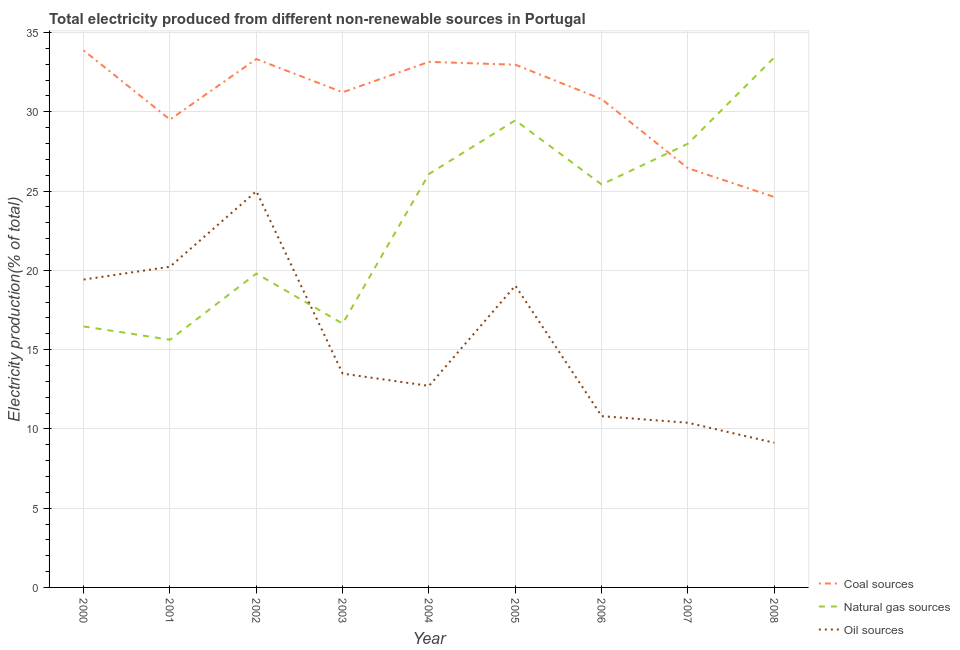Is the number of lines equal to the number of legend labels?
Offer a very short reply. Yes. What is the percentage of electricity produced by natural gas in 2004?
Your answer should be compact. 26.08. Across all years, what is the maximum percentage of electricity produced by coal?
Provide a short and direct response. 33.87. Across all years, what is the minimum percentage of electricity produced by natural gas?
Offer a very short reply. 15.62. What is the total percentage of electricity produced by coal in the graph?
Offer a very short reply. 275.88. What is the difference between the percentage of electricity produced by coal in 2000 and that in 2001?
Provide a short and direct response. 4.36. What is the difference between the percentage of electricity produced by oil sources in 2005 and the percentage of electricity produced by coal in 2001?
Your answer should be compact. -10.47. What is the average percentage of electricity produced by oil sources per year?
Your answer should be compact. 15.57. In the year 2008, what is the difference between the percentage of electricity produced by coal and percentage of electricity produced by oil sources?
Provide a succinct answer. 15.5. In how many years, is the percentage of electricity produced by oil sources greater than 27 %?
Keep it short and to the point. 0. What is the ratio of the percentage of electricity produced by natural gas in 2002 to that in 2003?
Offer a terse response. 1.19. Is the percentage of electricity produced by coal in 2002 less than that in 2006?
Offer a terse response. No. What is the difference between the highest and the second highest percentage of electricity produced by natural gas?
Give a very brief answer. 3.97. What is the difference between the highest and the lowest percentage of electricity produced by oil sources?
Give a very brief answer. 15.87. Is it the case that in every year, the sum of the percentage of electricity produced by coal and percentage of electricity produced by natural gas is greater than the percentage of electricity produced by oil sources?
Keep it short and to the point. Yes. Does the percentage of electricity produced by natural gas monotonically increase over the years?
Offer a terse response. No. Is the percentage of electricity produced by natural gas strictly greater than the percentage of electricity produced by coal over the years?
Your answer should be compact. No. Is the percentage of electricity produced by coal strictly less than the percentage of electricity produced by natural gas over the years?
Give a very brief answer. No. Does the graph contain any zero values?
Ensure brevity in your answer.  No. Does the graph contain grids?
Provide a short and direct response. Yes. Where does the legend appear in the graph?
Your response must be concise. Bottom right. How are the legend labels stacked?
Offer a terse response. Vertical. What is the title of the graph?
Give a very brief answer. Total electricity produced from different non-renewable sources in Portugal. What is the label or title of the Y-axis?
Ensure brevity in your answer.  Electricity production(% of total). What is the Electricity production(% of total) of Coal sources in 2000?
Provide a succinct answer. 33.87. What is the Electricity production(% of total) of Natural gas sources in 2000?
Your response must be concise. 16.46. What is the Electricity production(% of total) in Oil sources in 2000?
Your answer should be compact. 19.42. What is the Electricity production(% of total) of Coal sources in 2001?
Provide a succinct answer. 29.51. What is the Electricity production(% of total) of Natural gas sources in 2001?
Give a very brief answer. 15.62. What is the Electricity production(% of total) in Oil sources in 2001?
Give a very brief answer. 20.23. What is the Electricity production(% of total) of Coal sources in 2002?
Offer a very short reply. 33.32. What is the Electricity production(% of total) in Natural gas sources in 2002?
Make the answer very short. 19.8. What is the Electricity production(% of total) in Oil sources in 2002?
Offer a terse response. 24.99. What is the Electricity production(% of total) in Coal sources in 2003?
Ensure brevity in your answer.  31.23. What is the Electricity production(% of total) in Natural gas sources in 2003?
Provide a short and direct response. 16.64. What is the Electricity production(% of total) in Oil sources in 2003?
Ensure brevity in your answer.  13.48. What is the Electricity production(% of total) of Coal sources in 2004?
Your answer should be compact. 33.15. What is the Electricity production(% of total) of Natural gas sources in 2004?
Make the answer very short. 26.08. What is the Electricity production(% of total) of Oil sources in 2004?
Ensure brevity in your answer.  12.71. What is the Electricity production(% of total) in Coal sources in 2005?
Keep it short and to the point. 32.97. What is the Electricity production(% of total) of Natural gas sources in 2005?
Ensure brevity in your answer.  29.46. What is the Electricity production(% of total) of Oil sources in 2005?
Provide a succinct answer. 19.03. What is the Electricity production(% of total) in Coal sources in 2006?
Keep it short and to the point. 30.79. What is the Electricity production(% of total) of Natural gas sources in 2006?
Your answer should be very brief. 25.41. What is the Electricity production(% of total) in Oil sources in 2006?
Provide a succinct answer. 10.8. What is the Electricity production(% of total) in Coal sources in 2007?
Offer a very short reply. 26.44. What is the Electricity production(% of total) in Natural gas sources in 2007?
Give a very brief answer. 27.99. What is the Electricity production(% of total) of Oil sources in 2007?
Ensure brevity in your answer.  10.38. What is the Electricity production(% of total) in Coal sources in 2008?
Ensure brevity in your answer.  24.62. What is the Electricity production(% of total) in Natural gas sources in 2008?
Provide a short and direct response. 33.43. What is the Electricity production(% of total) of Oil sources in 2008?
Provide a succinct answer. 9.12. Across all years, what is the maximum Electricity production(% of total) in Coal sources?
Provide a short and direct response. 33.87. Across all years, what is the maximum Electricity production(% of total) in Natural gas sources?
Your answer should be compact. 33.43. Across all years, what is the maximum Electricity production(% of total) in Oil sources?
Provide a succinct answer. 24.99. Across all years, what is the minimum Electricity production(% of total) of Coal sources?
Provide a short and direct response. 24.62. Across all years, what is the minimum Electricity production(% of total) in Natural gas sources?
Offer a terse response. 15.62. Across all years, what is the minimum Electricity production(% of total) in Oil sources?
Offer a very short reply. 9.12. What is the total Electricity production(% of total) in Coal sources in the graph?
Ensure brevity in your answer.  275.88. What is the total Electricity production(% of total) of Natural gas sources in the graph?
Your answer should be very brief. 210.87. What is the total Electricity production(% of total) of Oil sources in the graph?
Provide a succinct answer. 140.17. What is the difference between the Electricity production(% of total) of Coal sources in 2000 and that in 2001?
Provide a succinct answer. 4.36. What is the difference between the Electricity production(% of total) in Natural gas sources in 2000 and that in 2001?
Make the answer very short. 0.84. What is the difference between the Electricity production(% of total) in Oil sources in 2000 and that in 2001?
Offer a very short reply. -0.81. What is the difference between the Electricity production(% of total) of Coal sources in 2000 and that in 2002?
Offer a very short reply. 0.54. What is the difference between the Electricity production(% of total) of Natural gas sources in 2000 and that in 2002?
Provide a short and direct response. -3.34. What is the difference between the Electricity production(% of total) in Oil sources in 2000 and that in 2002?
Your answer should be very brief. -5.57. What is the difference between the Electricity production(% of total) of Coal sources in 2000 and that in 2003?
Keep it short and to the point. 2.64. What is the difference between the Electricity production(% of total) in Natural gas sources in 2000 and that in 2003?
Your answer should be compact. -0.18. What is the difference between the Electricity production(% of total) of Oil sources in 2000 and that in 2003?
Provide a short and direct response. 5.93. What is the difference between the Electricity production(% of total) in Coal sources in 2000 and that in 2004?
Your answer should be very brief. 0.72. What is the difference between the Electricity production(% of total) of Natural gas sources in 2000 and that in 2004?
Give a very brief answer. -9.62. What is the difference between the Electricity production(% of total) in Oil sources in 2000 and that in 2004?
Offer a terse response. 6.7. What is the difference between the Electricity production(% of total) of Coal sources in 2000 and that in 2005?
Offer a terse response. 0.9. What is the difference between the Electricity production(% of total) of Natural gas sources in 2000 and that in 2005?
Ensure brevity in your answer.  -13. What is the difference between the Electricity production(% of total) of Oil sources in 2000 and that in 2005?
Offer a very short reply. 0.38. What is the difference between the Electricity production(% of total) of Coal sources in 2000 and that in 2006?
Keep it short and to the point. 3.07. What is the difference between the Electricity production(% of total) in Natural gas sources in 2000 and that in 2006?
Provide a short and direct response. -8.95. What is the difference between the Electricity production(% of total) of Oil sources in 2000 and that in 2006?
Make the answer very short. 8.61. What is the difference between the Electricity production(% of total) in Coal sources in 2000 and that in 2007?
Your answer should be compact. 7.43. What is the difference between the Electricity production(% of total) of Natural gas sources in 2000 and that in 2007?
Offer a terse response. -11.53. What is the difference between the Electricity production(% of total) of Oil sources in 2000 and that in 2007?
Offer a very short reply. 9.03. What is the difference between the Electricity production(% of total) in Coal sources in 2000 and that in 2008?
Your answer should be very brief. 9.24. What is the difference between the Electricity production(% of total) of Natural gas sources in 2000 and that in 2008?
Make the answer very short. -16.97. What is the difference between the Electricity production(% of total) in Oil sources in 2000 and that in 2008?
Provide a short and direct response. 10.29. What is the difference between the Electricity production(% of total) in Coal sources in 2001 and that in 2002?
Make the answer very short. -3.82. What is the difference between the Electricity production(% of total) in Natural gas sources in 2001 and that in 2002?
Make the answer very short. -4.18. What is the difference between the Electricity production(% of total) in Oil sources in 2001 and that in 2002?
Ensure brevity in your answer.  -4.76. What is the difference between the Electricity production(% of total) of Coal sources in 2001 and that in 2003?
Keep it short and to the point. -1.72. What is the difference between the Electricity production(% of total) of Natural gas sources in 2001 and that in 2003?
Your answer should be very brief. -1.02. What is the difference between the Electricity production(% of total) in Oil sources in 2001 and that in 2003?
Give a very brief answer. 6.74. What is the difference between the Electricity production(% of total) of Coal sources in 2001 and that in 2004?
Your answer should be very brief. -3.64. What is the difference between the Electricity production(% of total) of Natural gas sources in 2001 and that in 2004?
Provide a short and direct response. -10.45. What is the difference between the Electricity production(% of total) of Oil sources in 2001 and that in 2004?
Offer a very short reply. 7.51. What is the difference between the Electricity production(% of total) in Coal sources in 2001 and that in 2005?
Ensure brevity in your answer.  -3.46. What is the difference between the Electricity production(% of total) in Natural gas sources in 2001 and that in 2005?
Offer a terse response. -13.84. What is the difference between the Electricity production(% of total) in Oil sources in 2001 and that in 2005?
Make the answer very short. 1.19. What is the difference between the Electricity production(% of total) in Coal sources in 2001 and that in 2006?
Your answer should be very brief. -1.29. What is the difference between the Electricity production(% of total) of Natural gas sources in 2001 and that in 2006?
Provide a succinct answer. -9.79. What is the difference between the Electricity production(% of total) in Oil sources in 2001 and that in 2006?
Ensure brevity in your answer.  9.42. What is the difference between the Electricity production(% of total) of Coal sources in 2001 and that in 2007?
Provide a succinct answer. 3.07. What is the difference between the Electricity production(% of total) of Natural gas sources in 2001 and that in 2007?
Your response must be concise. -12.36. What is the difference between the Electricity production(% of total) in Oil sources in 2001 and that in 2007?
Make the answer very short. 9.84. What is the difference between the Electricity production(% of total) in Coal sources in 2001 and that in 2008?
Offer a terse response. 4.88. What is the difference between the Electricity production(% of total) of Natural gas sources in 2001 and that in 2008?
Provide a succinct answer. -17.8. What is the difference between the Electricity production(% of total) in Oil sources in 2001 and that in 2008?
Provide a short and direct response. 11.1. What is the difference between the Electricity production(% of total) of Coal sources in 2002 and that in 2003?
Give a very brief answer. 2.1. What is the difference between the Electricity production(% of total) in Natural gas sources in 2002 and that in 2003?
Give a very brief answer. 3.16. What is the difference between the Electricity production(% of total) in Oil sources in 2002 and that in 2003?
Provide a succinct answer. 11.5. What is the difference between the Electricity production(% of total) of Coal sources in 2002 and that in 2004?
Offer a very short reply. 0.18. What is the difference between the Electricity production(% of total) of Natural gas sources in 2002 and that in 2004?
Keep it short and to the point. -6.28. What is the difference between the Electricity production(% of total) in Oil sources in 2002 and that in 2004?
Your response must be concise. 12.28. What is the difference between the Electricity production(% of total) in Coal sources in 2002 and that in 2005?
Offer a terse response. 0.36. What is the difference between the Electricity production(% of total) of Natural gas sources in 2002 and that in 2005?
Give a very brief answer. -9.66. What is the difference between the Electricity production(% of total) of Oil sources in 2002 and that in 2005?
Your answer should be compact. 5.95. What is the difference between the Electricity production(% of total) of Coal sources in 2002 and that in 2006?
Your response must be concise. 2.53. What is the difference between the Electricity production(% of total) in Natural gas sources in 2002 and that in 2006?
Your response must be concise. -5.61. What is the difference between the Electricity production(% of total) of Oil sources in 2002 and that in 2006?
Your response must be concise. 14.19. What is the difference between the Electricity production(% of total) in Coal sources in 2002 and that in 2007?
Your answer should be very brief. 6.89. What is the difference between the Electricity production(% of total) in Natural gas sources in 2002 and that in 2007?
Your answer should be compact. -8.19. What is the difference between the Electricity production(% of total) in Oil sources in 2002 and that in 2007?
Provide a succinct answer. 14.6. What is the difference between the Electricity production(% of total) of Coal sources in 2002 and that in 2008?
Your answer should be very brief. 8.7. What is the difference between the Electricity production(% of total) of Natural gas sources in 2002 and that in 2008?
Your response must be concise. -13.63. What is the difference between the Electricity production(% of total) of Oil sources in 2002 and that in 2008?
Your answer should be compact. 15.87. What is the difference between the Electricity production(% of total) of Coal sources in 2003 and that in 2004?
Provide a succinct answer. -1.92. What is the difference between the Electricity production(% of total) of Natural gas sources in 2003 and that in 2004?
Your response must be concise. -9.44. What is the difference between the Electricity production(% of total) in Oil sources in 2003 and that in 2004?
Keep it short and to the point. 0.77. What is the difference between the Electricity production(% of total) in Coal sources in 2003 and that in 2005?
Your answer should be compact. -1.74. What is the difference between the Electricity production(% of total) in Natural gas sources in 2003 and that in 2005?
Your answer should be compact. -12.82. What is the difference between the Electricity production(% of total) of Oil sources in 2003 and that in 2005?
Keep it short and to the point. -5.55. What is the difference between the Electricity production(% of total) of Coal sources in 2003 and that in 2006?
Offer a very short reply. 0.43. What is the difference between the Electricity production(% of total) of Natural gas sources in 2003 and that in 2006?
Offer a very short reply. -8.77. What is the difference between the Electricity production(% of total) of Oil sources in 2003 and that in 2006?
Your answer should be compact. 2.68. What is the difference between the Electricity production(% of total) of Coal sources in 2003 and that in 2007?
Your response must be concise. 4.79. What is the difference between the Electricity production(% of total) in Natural gas sources in 2003 and that in 2007?
Offer a terse response. -11.35. What is the difference between the Electricity production(% of total) in Oil sources in 2003 and that in 2007?
Your answer should be compact. 3.1. What is the difference between the Electricity production(% of total) of Coal sources in 2003 and that in 2008?
Make the answer very short. 6.6. What is the difference between the Electricity production(% of total) of Natural gas sources in 2003 and that in 2008?
Keep it short and to the point. -16.79. What is the difference between the Electricity production(% of total) in Oil sources in 2003 and that in 2008?
Your answer should be compact. 4.36. What is the difference between the Electricity production(% of total) of Coal sources in 2004 and that in 2005?
Offer a very short reply. 0.18. What is the difference between the Electricity production(% of total) in Natural gas sources in 2004 and that in 2005?
Offer a terse response. -3.38. What is the difference between the Electricity production(% of total) of Oil sources in 2004 and that in 2005?
Provide a short and direct response. -6.32. What is the difference between the Electricity production(% of total) of Coal sources in 2004 and that in 2006?
Make the answer very short. 2.35. What is the difference between the Electricity production(% of total) in Natural gas sources in 2004 and that in 2006?
Ensure brevity in your answer.  0.67. What is the difference between the Electricity production(% of total) in Oil sources in 2004 and that in 2006?
Give a very brief answer. 1.91. What is the difference between the Electricity production(% of total) in Coal sources in 2004 and that in 2007?
Offer a terse response. 6.71. What is the difference between the Electricity production(% of total) in Natural gas sources in 2004 and that in 2007?
Your response must be concise. -1.91. What is the difference between the Electricity production(% of total) of Oil sources in 2004 and that in 2007?
Give a very brief answer. 2.33. What is the difference between the Electricity production(% of total) of Coal sources in 2004 and that in 2008?
Give a very brief answer. 8.52. What is the difference between the Electricity production(% of total) in Natural gas sources in 2004 and that in 2008?
Provide a short and direct response. -7.35. What is the difference between the Electricity production(% of total) in Oil sources in 2004 and that in 2008?
Provide a succinct answer. 3.59. What is the difference between the Electricity production(% of total) in Coal sources in 2005 and that in 2006?
Ensure brevity in your answer.  2.17. What is the difference between the Electricity production(% of total) in Natural gas sources in 2005 and that in 2006?
Provide a short and direct response. 4.05. What is the difference between the Electricity production(% of total) in Oil sources in 2005 and that in 2006?
Your answer should be compact. 8.23. What is the difference between the Electricity production(% of total) in Coal sources in 2005 and that in 2007?
Give a very brief answer. 6.53. What is the difference between the Electricity production(% of total) in Natural gas sources in 2005 and that in 2007?
Your answer should be compact. 1.47. What is the difference between the Electricity production(% of total) of Oil sources in 2005 and that in 2007?
Provide a succinct answer. 8.65. What is the difference between the Electricity production(% of total) of Coal sources in 2005 and that in 2008?
Keep it short and to the point. 8.34. What is the difference between the Electricity production(% of total) in Natural gas sources in 2005 and that in 2008?
Offer a very short reply. -3.97. What is the difference between the Electricity production(% of total) in Oil sources in 2005 and that in 2008?
Provide a short and direct response. 9.91. What is the difference between the Electricity production(% of total) in Coal sources in 2006 and that in 2007?
Your response must be concise. 4.36. What is the difference between the Electricity production(% of total) of Natural gas sources in 2006 and that in 2007?
Offer a very short reply. -2.58. What is the difference between the Electricity production(% of total) in Oil sources in 2006 and that in 2007?
Offer a terse response. 0.42. What is the difference between the Electricity production(% of total) of Coal sources in 2006 and that in 2008?
Provide a succinct answer. 6.17. What is the difference between the Electricity production(% of total) of Natural gas sources in 2006 and that in 2008?
Ensure brevity in your answer.  -8.02. What is the difference between the Electricity production(% of total) of Oil sources in 2006 and that in 2008?
Ensure brevity in your answer.  1.68. What is the difference between the Electricity production(% of total) in Coal sources in 2007 and that in 2008?
Your answer should be compact. 1.81. What is the difference between the Electricity production(% of total) in Natural gas sources in 2007 and that in 2008?
Ensure brevity in your answer.  -5.44. What is the difference between the Electricity production(% of total) of Oil sources in 2007 and that in 2008?
Your response must be concise. 1.26. What is the difference between the Electricity production(% of total) in Coal sources in 2000 and the Electricity production(% of total) in Natural gas sources in 2001?
Give a very brief answer. 18.24. What is the difference between the Electricity production(% of total) in Coal sources in 2000 and the Electricity production(% of total) in Oil sources in 2001?
Ensure brevity in your answer.  13.64. What is the difference between the Electricity production(% of total) in Natural gas sources in 2000 and the Electricity production(% of total) in Oil sources in 2001?
Offer a terse response. -3.77. What is the difference between the Electricity production(% of total) of Coal sources in 2000 and the Electricity production(% of total) of Natural gas sources in 2002?
Provide a succinct answer. 14.07. What is the difference between the Electricity production(% of total) in Coal sources in 2000 and the Electricity production(% of total) in Oil sources in 2002?
Provide a succinct answer. 8.88. What is the difference between the Electricity production(% of total) of Natural gas sources in 2000 and the Electricity production(% of total) of Oil sources in 2002?
Your answer should be very brief. -8.53. What is the difference between the Electricity production(% of total) in Coal sources in 2000 and the Electricity production(% of total) in Natural gas sources in 2003?
Keep it short and to the point. 17.23. What is the difference between the Electricity production(% of total) of Coal sources in 2000 and the Electricity production(% of total) of Oil sources in 2003?
Your answer should be very brief. 20.38. What is the difference between the Electricity production(% of total) in Natural gas sources in 2000 and the Electricity production(% of total) in Oil sources in 2003?
Make the answer very short. 2.97. What is the difference between the Electricity production(% of total) in Coal sources in 2000 and the Electricity production(% of total) in Natural gas sources in 2004?
Make the answer very short. 7.79. What is the difference between the Electricity production(% of total) in Coal sources in 2000 and the Electricity production(% of total) in Oil sources in 2004?
Ensure brevity in your answer.  21.15. What is the difference between the Electricity production(% of total) in Natural gas sources in 2000 and the Electricity production(% of total) in Oil sources in 2004?
Make the answer very short. 3.75. What is the difference between the Electricity production(% of total) of Coal sources in 2000 and the Electricity production(% of total) of Natural gas sources in 2005?
Your answer should be very brief. 4.41. What is the difference between the Electricity production(% of total) in Coal sources in 2000 and the Electricity production(% of total) in Oil sources in 2005?
Make the answer very short. 14.83. What is the difference between the Electricity production(% of total) of Natural gas sources in 2000 and the Electricity production(% of total) of Oil sources in 2005?
Offer a very short reply. -2.58. What is the difference between the Electricity production(% of total) of Coal sources in 2000 and the Electricity production(% of total) of Natural gas sources in 2006?
Provide a succinct answer. 8.46. What is the difference between the Electricity production(% of total) of Coal sources in 2000 and the Electricity production(% of total) of Oil sources in 2006?
Ensure brevity in your answer.  23.06. What is the difference between the Electricity production(% of total) of Natural gas sources in 2000 and the Electricity production(% of total) of Oil sources in 2006?
Offer a very short reply. 5.66. What is the difference between the Electricity production(% of total) of Coal sources in 2000 and the Electricity production(% of total) of Natural gas sources in 2007?
Give a very brief answer. 5.88. What is the difference between the Electricity production(% of total) in Coal sources in 2000 and the Electricity production(% of total) in Oil sources in 2007?
Make the answer very short. 23.48. What is the difference between the Electricity production(% of total) in Natural gas sources in 2000 and the Electricity production(% of total) in Oil sources in 2007?
Offer a very short reply. 6.07. What is the difference between the Electricity production(% of total) of Coal sources in 2000 and the Electricity production(% of total) of Natural gas sources in 2008?
Ensure brevity in your answer.  0.44. What is the difference between the Electricity production(% of total) in Coal sources in 2000 and the Electricity production(% of total) in Oil sources in 2008?
Make the answer very short. 24.74. What is the difference between the Electricity production(% of total) of Natural gas sources in 2000 and the Electricity production(% of total) of Oil sources in 2008?
Your answer should be compact. 7.34. What is the difference between the Electricity production(% of total) in Coal sources in 2001 and the Electricity production(% of total) in Natural gas sources in 2002?
Offer a terse response. 9.71. What is the difference between the Electricity production(% of total) of Coal sources in 2001 and the Electricity production(% of total) of Oil sources in 2002?
Ensure brevity in your answer.  4.52. What is the difference between the Electricity production(% of total) of Natural gas sources in 2001 and the Electricity production(% of total) of Oil sources in 2002?
Make the answer very short. -9.37. What is the difference between the Electricity production(% of total) in Coal sources in 2001 and the Electricity production(% of total) in Natural gas sources in 2003?
Offer a very short reply. 12.87. What is the difference between the Electricity production(% of total) in Coal sources in 2001 and the Electricity production(% of total) in Oil sources in 2003?
Offer a very short reply. 16.02. What is the difference between the Electricity production(% of total) in Natural gas sources in 2001 and the Electricity production(% of total) in Oil sources in 2003?
Keep it short and to the point. 2.14. What is the difference between the Electricity production(% of total) of Coal sources in 2001 and the Electricity production(% of total) of Natural gas sources in 2004?
Give a very brief answer. 3.43. What is the difference between the Electricity production(% of total) of Coal sources in 2001 and the Electricity production(% of total) of Oil sources in 2004?
Offer a very short reply. 16.79. What is the difference between the Electricity production(% of total) in Natural gas sources in 2001 and the Electricity production(% of total) in Oil sources in 2004?
Give a very brief answer. 2.91. What is the difference between the Electricity production(% of total) of Coal sources in 2001 and the Electricity production(% of total) of Natural gas sources in 2005?
Your answer should be compact. 0.05. What is the difference between the Electricity production(% of total) in Coal sources in 2001 and the Electricity production(% of total) in Oil sources in 2005?
Offer a very short reply. 10.47. What is the difference between the Electricity production(% of total) of Natural gas sources in 2001 and the Electricity production(% of total) of Oil sources in 2005?
Give a very brief answer. -3.41. What is the difference between the Electricity production(% of total) in Coal sources in 2001 and the Electricity production(% of total) in Natural gas sources in 2006?
Provide a short and direct response. 4.1. What is the difference between the Electricity production(% of total) in Coal sources in 2001 and the Electricity production(% of total) in Oil sources in 2006?
Make the answer very short. 18.7. What is the difference between the Electricity production(% of total) of Natural gas sources in 2001 and the Electricity production(% of total) of Oil sources in 2006?
Your answer should be very brief. 4.82. What is the difference between the Electricity production(% of total) in Coal sources in 2001 and the Electricity production(% of total) in Natural gas sources in 2007?
Your answer should be very brief. 1.52. What is the difference between the Electricity production(% of total) of Coal sources in 2001 and the Electricity production(% of total) of Oil sources in 2007?
Your answer should be very brief. 19.12. What is the difference between the Electricity production(% of total) of Natural gas sources in 2001 and the Electricity production(% of total) of Oil sources in 2007?
Your answer should be very brief. 5.24. What is the difference between the Electricity production(% of total) in Coal sources in 2001 and the Electricity production(% of total) in Natural gas sources in 2008?
Make the answer very short. -3.92. What is the difference between the Electricity production(% of total) in Coal sources in 2001 and the Electricity production(% of total) in Oil sources in 2008?
Provide a succinct answer. 20.38. What is the difference between the Electricity production(% of total) in Natural gas sources in 2001 and the Electricity production(% of total) in Oil sources in 2008?
Your answer should be very brief. 6.5. What is the difference between the Electricity production(% of total) of Coal sources in 2002 and the Electricity production(% of total) of Natural gas sources in 2003?
Your answer should be very brief. 16.69. What is the difference between the Electricity production(% of total) of Coal sources in 2002 and the Electricity production(% of total) of Oil sources in 2003?
Make the answer very short. 19.84. What is the difference between the Electricity production(% of total) in Natural gas sources in 2002 and the Electricity production(% of total) in Oil sources in 2003?
Your response must be concise. 6.31. What is the difference between the Electricity production(% of total) of Coal sources in 2002 and the Electricity production(% of total) of Natural gas sources in 2004?
Provide a short and direct response. 7.25. What is the difference between the Electricity production(% of total) of Coal sources in 2002 and the Electricity production(% of total) of Oil sources in 2004?
Give a very brief answer. 20.61. What is the difference between the Electricity production(% of total) in Natural gas sources in 2002 and the Electricity production(% of total) in Oil sources in 2004?
Provide a short and direct response. 7.09. What is the difference between the Electricity production(% of total) of Coal sources in 2002 and the Electricity production(% of total) of Natural gas sources in 2005?
Give a very brief answer. 3.87. What is the difference between the Electricity production(% of total) in Coal sources in 2002 and the Electricity production(% of total) in Oil sources in 2005?
Give a very brief answer. 14.29. What is the difference between the Electricity production(% of total) in Natural gas sources in 2002 and the Electricity production(% of total) in Oil sources in 2005?
Your response must be concise. 0.76. What is the difference between the Electricity production(% of total) of Coal sources in 2002 and the Electricity production(% of total) of Natural gas sources in 2006?
Give a very brief answer. 7.91. What is the difference between the Electricity production(% of total) in Coal sources in 2002 and the Electricity production(% of total) in Oil sources in 2006?
Your response must be concise. 22.52. What is the difference between the Electricity production(% of total) in Natural gas sources in 2002 and the Electricity production(% of total) in Oil sources in 2006?
Provide a succinct answer. 8.99. What is the difference between the Electricity production(% of total) of Coal sources in 2002 and the Electricity production(% of total) of Natural gas sources in 2007?
Give a very brief answer. 5.34. What is the difference between the Electricity production(% of total) of Coal sources in 2002 and the Electricity production(% of total) of Oil sources in 2007?
Offer a very short reply. 22.94. What is the difference between the Electricity production(% of total) in Natural gas sources in 2002 and the Electricity production(% of total) in Oil sources in 2007?
Offer a very short reply. 9.41. What is the difference between the Electricity production(% of total) in Coal sources in 2002 and the Electricity production(% of total) in Natural gas sources in 2008?
Keep it short and to the point. -0.1. What is the difference between the Electricity production(% of total) of Coal sources in 2002 and the Electricity production(% of total) of Oil sources in 2008?
Give a very brief answer. 24.2. What is the difference between the Electricity production(% of total) of Natural gas sources in 2002 and the Electricity production(% of total) of Oil sources in 2008?
Keep it short and to the point. 10.67. What is the difference between the Electricity production(% of total) of Coal sources in 2003 and the Electricity production(% of total) of Natural gas sources in 2004?
Your answer should be very brief. 5.15. What is the difference between the Electricity production(% of total) of Coal sources in 2003 and the Electricity production(% of total) of Oil sources in 2004?
Keep it short and to the point. 18.52. What is the difference between the Electricity production(% of total) of Natural gas sources in 2003 and the Electricity production(% of total) of Oil sources in 2004?
Your response must be concise. 3.93. What is the difference between the Electricity production(% of total) of Coal sources in 2003 and the Electricity production(% of total) of Natural gas sources in 2005?
Give a very brief answer. 1.77. What is the difference between the Electricity production(% of total) in Coal sources in 2003 and the Electricity production(% of total) in Oil sources in 2005?
Make the answer very short. 12.19. What is the difference between the Electricity production(% of total) in Natural gas sources in 2003 and the Electricity production(% of total) in Oil sources in 2005?
Your answer should be compact. -2.4. What is the difference between the Electricity production(% of total) in Coal sources in 2003 and the Electricity production(% of total) in Natural gas sources in 2006?
Make the answer very short. 5.82. What is the difference between the Electricity production(% of total) of Coal sources in 2003 and the Electricity production(% of total) of Oil sources in 2006?
Your response must be concise. 20.43. What is the difference between the Electricity production(% of total) in Natural gas sources in 2003 and the Electricity production(% of total) in Oil sources in 2006?
Provide a succinct answer. 5.84. What is the difference between the Electricity production(% of total) in Coal sources in 2003 and the Electricity production(% of total) in Natural gas sources in 2007?
Offer a very short reply. 3.24. What is the difference between the Electricity production(% of total) of Coal sources in 2003 and the Electricity production(% of total) of Oil sources in 2007?
Make the answer very short. 20.84. What is the difference between the Electricity production(% of total) of Natural gas sources in 2003 and the Electricity production(% of total) of Oil sources in 2007?
Offer a very short reply. 6.25. What is the difference between the Electricity production(% of total) in Coal sources in 2003 and the Electricity production(% of total) in Natural gas sources in 2008?
Make the answer very short. -2.2. What is the difference between the Electricity production(% of total) of Coal sources in 2003 and the Electricity production(% of total) of Oil sources in 2008?
Give a very brief answer. 22.1. What is the difference between the Electricity production(% of total) in Natural gas sources in 2003 and the Electricity production(% of total) in Oil sources in 2008?
Offer a terse response. 7.52. What is the difference between the Electricity production(% of total) of Coal sources in 2004 and the Electricity production(% of total) of Natural gas sources in 2005?
Make the answer very short. 3.69. What is the difference between the Electricity production(% of total) of Coal sources in 2004 and the Electricity production(% of total) of Oil sources in 2005?
Your answer should be very brief. 14.11. What is the difference between the Electricity production(% of total) of Natural gas sources in 2004 and the Electricity production(% of total) of Oil sources in 2005?
Keep it short and to the point. 7.04. What is the difference between the Electricity production(% of total) in Coal sources in 2004 and the Electricity production(% of total) in Natural gas sources in 2006?
Offer a terse response. 7.74. What is the difference between the Electricity production(% of total) in Coal sources in 2004 and the Electricity production(% of total) in Oil sources in 2006?
Provide a short and direct response. 22.34. What is the difference between the Electricity production(% of total) in Natural gas sources in 2004 and the Electricity production(% of total) in Oil sources in 2006?
Provide a succinct answer. 15.27. What is the difference between the Electricity production(% of total) of Coal sources in 2004 and the Electricity production(% of total) of Natural gas sources in 2007?
Your response must be concise. 5.16. What is the difference between the Electricity production(% of total) in Coal sources in 2004 and the Electricity production(% of total) in Oil sources in 2007?
Keep it short and to the point. 22.76. What is the difference between the Electricity production(% of total) of Natural gas sources in 2004 and the Electricity production(% of total) of Oil sources in 2007?
Offer a very short reply. 15.69. What is the difference between the Electricity production(% of total) of Coal sources in 2004 and the Electricity production(% of total) of Natural gas sources in 2008?
Provide a succinct answer. -0.28. What is the difference between the Electricity production(% of total) of Coal sources in 2004 and the Electricity production(% of total) of Oil sources in 2008?
Provide a succinct answer. 24.02. What is the difference between the Electricity production(% of total) of Natural gas sources in 2004 and the Electricity production(% of total) of Oil sources in 2008?
Your response must be concise. 16.95. What is the difference between the Electricity production(% of total) in Coal sources in 2005 and the Electricity production(% of total) in Natural gas sources in 2006?
Provide a succinct answer. 7.56. What is the difference between the Electricity production(% of total) in Coal sources in 2005 and the Electricity production(% of total) in Oil sources in 2006?
Offer a terse response. 22.16. What is the difference between the Electricity production(% of total) in Natural gas sources in 2005 and the Electricity production(% of total) in Oil sources in 2006?
Your answer should be compact. 18.66. What is the difference between the Electricity production(% of total) in Coal sources in 2005 and the Electricity production(% of total) in Natural gas sources in 2007?
Offer a terse response. 4.98. What is the difference between the Electricity production(% of total) in Coal sources in 2005 and the Electricity production(% of total) in Oil sources in 2007?
Offer a very short reply. 22.58. What is the difference between the Electricity production(% of total) in Natural gas sources in 2005 and the Electricity production(% of total) in Oil sources in 2007?
Offer a terse response. 19.07. What is the difference between the Electricity production(% of total) of Coal sources in 2005 and the Electricity production(% of total) of Natural gas sources in 2008?
Give a very brief answer. -0.46. What is the difference between the Electricity production(% of total) of Coal sources in 2005 and the Electricity production(% of total) of Oil sources in 2008?
Your response must be concise. 23.84. What is the difference between the Electricity production(% of total) of Natural gas sources in 2005 and the Electricity production(% of total) of Oil sources in 2008?
Your answer should be compact. 20.34. What is the difference between the Electricity production(% of total) of Coal sources in 2006 and the Electricity production(% of total) of Natural gas sources in 2007?
Provide a succinct answer. 2.81. What is the difference between the Electricity production(% of total) in Coal sources in 2006 and the Electricity production(% of total) in Oil sources in 2007?
Make the answer very short. 20.41. What is the difference between the Electricity production(% of total) in Natural gas sources in 2006 and the Electricity production(% of total) in Oil sources in 2007?
Make the answer very short. 15.03. What is the difference between the Electricity production(% of total) in Coal sources in 2006 and the Electricity production(% of total) in Natural gas sources in 2008?
Give a very brief answer. -2.63. What is the difference between the Electricity production(% of total) of Coal sources in 2006 and the Electricity production(% of total) of Oil sources in 2008?
Offer a terse response. 21.67. What is the difference between the Electricity production(% of total) of Natural gas sources in 2006 and the Electricity production(% of total) of Oil sources in 2008?
Keep it short and to the point. 16.29. What is the difference between the Electricity production(% of total) of Coal sources in 2007 and the Electricity production(% of total) of Natural gas sources in 2008?
Your response must be concise. -6.99. What is the difference between the Electricity production(% of total) of Coal sources in 2007 and the Electricity production(% of total) of Oil sources in 2008?
Give a very brief answer. 17.31. What is the difference between the Electricity production(% of total) of Natural gas sources in 2007 and the Electricity production(% of total) of Oil sources in 2008?
Offer a very short reply. 18.86. What is the average Electricity production(% of total) in Coal sources per year?
Your response must be concise. 30.65. What is the average Electricity production(% of total) of Natural gas sources per year?
Offer a terse response. 23.43. What is the average Electricity production(% of total) of Oil sources per year?
Give a very brief answer. 15.57. In the year 2000, what is the difference between the Electricity production(% of total) in Coal sources and Electricity production(% of total) in Natural gas sources?
Offer a very short reply. 17.41. In the year 2000, what is the difference between the Electricity production(% of total) of Coal sources and Electricity production(% of total) of Oil sources?
Offer a very short reply. 14.45. In the year 2000, what is the difference between the Electricity production(% of total) of Natural gas sources and Electricity production(% of total) of Oil sources?
Make the answer very short. -2.96. In the year 2001, what is the difference between the Electricity production(% of total) of Coal sources and Electricity production(% of total) of Natural gas sources?
Provide a succinct answer. 13.88. In the year 2001, what is the difference between the Electricity production(% of total) in Coal sources and Electricity production(% of total) in Oil sources?
Give a very brief answer. 9.28. In the year 2001, what is the difference between the Electricity production(% of total) of Natural gas sources and Electricity production(% of total) of Oil sources?
Your answer should be very brief. -4.6. In the year 2002, what is the difference between the Electricity production(% of total) of Coal sources and Electricity production(% of total) of Natural gas sources?
Your answer should be compact. 13.53. In the year 2002, what is the difference between the Electricity production(% of total) of Coal sources and Electricity production(% of total) of Oil sources?
Your answer should be compact. 8.34. In the year 2002, what is the difference between the Electricity production(% of total) in Natural gas sources and Electricity production(% of total) in Oil sources?
Your response must be concise. -5.19. In the year 2003, what is the difference between the Electricity production(% of total) in Coal sources and Electricity production(% of total) in Natural gas sources?
Make the answer very short. 14.59. In the year 2003, what is the difference between the Electricity production(% of total) of Coal sources and Electricity production(% of total) of Oil sources?
Provide a succinct answer. 17.74. In the year 2003, what is the difference between the Electricity production(% of total) in Natural gas sources and Electricity production(% of total) in Oil sources?
Keep it short and to the point. 3.15. In the year 2004, what is the difference between the Electricity production(% of total) of Coal sources and Electricity production(% of total) of Natural gas sources?
Give a very brief answer. 7.07. In the year 2004, what is the difference between the Electricity production(% of total) of Coal sources and Electricity production(% of total) of Oil sources?
Make the answer very short. 20.43. In the year 2004, what is the difference between the Electricity production(% of total) in Natural gas sources and Electricity production(% of total) in Oil sources?
Keep it short and to the point. 13.36. In the year 2005, what is the difference between the Electricity production(% of total) of Coal sources and Electricity production(% of total) of Natural gas sources?
Provide a succinct answer. 3.51. In the year 2005, what is the difference between the Electricity production(% of total) of Coal sources and Electricity production(% of total) of Oil sources?
Ensure brevity in your answer.  13.93. In the year 2005, what is the difference between the Electricity production(% of total) of Natural gas sources and Electricity production(% of total) of Oil sources?
Give a very brief answer. 10.42. In the year 2006, what is the difference between the Electricity production(% of total) of Coal sources and Electricity production(% of total) of Natural gas sources?
Your response must be concise. 5.38. In the year 2006, what is the difference between the Electricity production(% of total) of Coal sources and Electricity production(% of total) of Oil sources?
Provide a short and direct response. 19.99. In the year 2006, what is the difference between the Electricity production(% of total) in Natural gas sources and Electricity production(% of total) in Oil sources?
Keep it short and to the point. 14.61. In the year 2007, what is the difference between the Electricity production(% of total) of Coal sources and Electricity production(% of total) of Natural gas sources?
Give a very brief answer. -1.55. In the year 2007, what is the difference between the Electricity production(% of total) of Coal sources and Electricity production(% of total) of Oil sources?
Your response must be concise. 16.05. In the year 2007, what is the difference between the Electricity production(% of total) in Natural gas sources and Electricity production(% of total) in Oil sources?
Provide a succinct answer. 17.6. In the year 2008, what is the difference between the Electricity production(% of total) in Coal sources and Electricity production(% of total) in Natural gas sources?
Make the answer very short. -8.8. In the year 2008, what is the difference between the Electricity production(% of total) of Natural gas sources and Electricity production(% of total) of Oil sources?
Provide a short and direct response. 24.3. What is the ratio of the Electricity production(% of total) in Coal sources in 2000 to that in 2001?
Provide a succinct answer. 1.15. What is the ratio of the Electricity production(% of total) in Natural gas sources in 2000 to that in 2001?
Offer a terse response. 1.05. What is the ratio of the Electricity production(% of total) of Oil sources in 2000 to that in 2001?
Make the answer very short. 0.96. What is the ratio of the Electricity production(% of total) in Coal sources in 2000 to that in 2002?
Give a very brief answer. 1.02. What is the ratio of the Electricity production(% of total) in Natural gas sources in 2000 to that in 2002?
Make the answer very short. 0.83. What is the ratio of the Electricity production(% of total) in Oil sources in 2000 to that in 2002?
Ensure brevity in your answer.  0.78. What is the ratio of the Electricity production(% of total) of Coal sources in 2000 to that in 2003?
Keep it short and to the point. 1.08. What is the ratio of the Electricity production(% of total) in Oil sources in 2000 to that in 2003?
Your answer should be very brief. 1.44. What is the ratio of the Electricity production(% of total) in Coal sources in 2000 to that in 2004?
Make the answer very short. 1.02. What is the ratio of the Electricity production(% of total) in Natural gas sources in 2000 to that in 2004?
Provide a short and direct response. 0.63. What is the ratio of the Electricity production(% of total) in Oil sources in 2000 to that in 2004?
Offer a terse response. 1.53. What is the ratio of the Electricity production(% of total) of Coal sources in 2000 to that in 2005?
Keep it short and to the point. 1.03. What is the ratio of the Electricity production(% of total) in Natural gas sources in 2000 to that in 2005?
Ensure brevity in your answer.  0.56. What is the ratio of the Electricity production(% of total) of Oil sources in 2000 to that in 2005?
Make the answer very short. 1.02. What is the ratio of the Electricity production(% of total) of Coal sources in 2000 to that in 2006?
Your response must be concise. 1.1. What is the ratio of the Electricity production(% of total) in Natural gas sources in 2000 to that in 2006?
Offer a very short reply. 0.65. What is the ratio of the Electricity production(% of total) of Oil sources in 2000 to that in 2006?
Give a very brief answer. 1.8. What is the ratio of the Electricity production(% of total) in Coal sources in 2000 to that in 2007?
Keep it short and to the point. 1.28. What is the ratio of the Electricity production(% of total) in Natural gas sources in 2000 to that in 2007?
Your answer should be very brief. 0.59. What is the ratio of the Electricity production(% of total) of Oil sources in 2000 to that in 2007?
Ensure brevity in your answer.  1.87. What is the ratio of the Electricity production(% of total) of Coal sources in 2000 to that in 2008?
Your answer should be compact. 1.38. What is the ratio of the Electricity production(% of total) of Natural gas sources in 2000 to that in 2008?
Keep it short and to the point. 0.49. What is the ratio of the Electricity production(% of total) of Oil sources in 2000 to that in 2008?
Your answer should be very brief. 2.13. What is the ratio of the Electricity production(% of total) of Coal sources in 2001 to that in 2002?
Ensure brevity in your answer.  0.89. What is the ratio of the Electricity production(% of total) of Natural gas sources in 2001 to that in 2002?
Offer a very short reply. 0.79. What is the ratio of the Electricity production(% of total) in Oil sources in 2001 to that in 2002?
Offer a terse response. 0.81. What is the ratio of the Electricity production(% of total) in Coal sources in 2001 to that in 2003?
Your response must be concise. 0.94. What is the ratio of the Electricity production(% of total) of Natural gas sources in 2001 to that in 2003?
Offer a very short reply. 0.94. What is the ratio of the Electricity production(% of total) of Coal sources in 2001 to that in 2004?
Offer a very short reply. 0.89. What is the ratio of the Electricity production(% of total) in Natural gas sources in 2001 to that in 2004?
Ensure brevity in your answer.  0.6. What is the ratio of the Electricity production(% of total) in Oil sources in 2001 to that in 2004?
Offer a terse response. 1.59. What is the ratio of the Electricity production(% of total) in Coal sources in 2001 to that in 2005?
Provide a short and direct response. 0.9. What is the ratio of the Electricity production(% of total) in Natural gas sources in 2001 to that in 2005?
Provide a succinct answer. 0.53. What is the ratio of the Electricity production(% of total) in Oil sources in 2001 to that in 2005?
Provide a short and direct response. 1.06. What is the ratio of the Electricity production(% of total) of Coal sources in 2001 to that in 2006?
Your answer should be very brief. 0.96. What is the ratio of the Electricity production(% of total) of Natural gas sources in 2001 to that in 2006?
Your answer should be very brief. 0.61. What is the ratio of the Electricity production(% of total) in Oil sources in 2001 to that in 2006?
Offer a terse response. 1.87. What is the ratio of the Electricity production(% of total) of Coal sources in 2001 to that in 2007?
Offer a very short reply. 1.12. What is the ratio of the Electricity production(% of total) of Natural gas sources in 2001 to that in 2007?
Your response must be concise. 0.56. What is the ratio of the Electricity production(% of total) of Oil sources in 2001 to that in 2007?
Provide a short and direct response. 1.95. What is the ratio of the Electricity production(% of total) in Coal sources in 2001 to that in 2008?
Provide a short and direct response. 1.2. What is the ratio of the Electricity production(% of total) in Natural gas sources in 2001 to that in 2008?
Your answer should be very brief. 0.47. What is the ratio of the Electricity production(% of total) of Oil sources in 2001 to that in 2008?
Offer a terse response. 2.22. What is the ratio of the Electricity production(% of total) of Coal sources in 2002 to that in 2003?
Provide a short and direct response. 1.07. What is the ratio of the Electricity production(% of total) in Natural gas sources in 2002 to that in 2003?
Ensure brevity in your answer.  1.19. What is the ratio of the Electricity production(% of total) in Oil sources in 2002 to that in 2003?
Offer a very short reply. 1.85. What is the ratio of the Electricity production(% of total) of Coal sources in 2002 to that in 2004?
Your answer should be compact. 1.01. What is the ratio of the Electricity production(% of total) of Natural gas sources in 2002 to that in 2004?
Provide a short and direct response. 0.76. What is the ratio of the Electricity production(% of total) of Oil sources in 2002 to that in 2004?
Give a very brief answer. 1.97. What is the ratio of the Electricity production(% of total) of Coal sources in 2002 to that in 2005?
Provide a succinct answer. 1.01. What is the ratio of the Electricity production(% of total) in Natural gas sources in 2002 to that in 2005?
Offer a very short reply. 0.67. What is the ratio of the Electricity production(% of total) in Oil sources in 2002 to that in 2005?
Your answer should be very brief. 1.31. What is the ratio of the Electricity production(% of total) of Coal sources in 2002 to that in 2006?
Provide a short and direct response. 1.08. What is the ratio of the Electricity production(% of total) of Natural gas sources in 2002 to that in 2006?
Ensure brevity in your answer.  0.78. What is the ratio of the Electricity production(% of total) in Oil sources in 2002 to that in 2006?
Keep it short and to the point. 2.31. What is the ratio of the Electricity production(% of total) in Coal sources in 2002 to that in 2007?
Make the answer very short. 1.26. What is the ratio of the Electricity production(% of total) of Natural gas sources in 2002 to that in 2007?
Keep it short and to the point. 0.71. What is the ratio of the Electricity production(% of total) in Oil sources in 2002 to that in 2007?
Ensure brevity in your answer.  2.41. What is the ratio of the Electricity production(% of total) in Coal sources in 2002 to that in 2008?
Provide a succinct answer. 1.35. What is the ratio of the Electricity production(% of total) of Natural gas sources in 2002 to that in 2008?
Provide a succinct answer. 0.59. What is the ratio of the Electricity production(% of total) in Oil sources in 2002 to that in 2008?
Make the answer very short. 2.74. What is the ratio of the Electricity production(% of total) in Coal sources in 2003 to that in 2004?
Provide a short and direct response. 0.94. What is the ratio of the Electricity production(% of total) of Natural gas sources in 2003 to that in 2004?
Your answer should be compact. 0.64. What is the ratio of the Electricity production(% of total) in Oil sources in 2003 to that in 2004?
Your response must be concise. 1.06. What is the ratio of the Electricity production(% of total) in Coal sources in 2003 to that in 2005?
Give a very brief answer. 0.95. What is the ratio of the Electricity production(% of total) of Natural gas sources in 2003 to that in 2005?
Your response must be concise. 0.56. What is the ratio of the Electricity production(% of total) of Oil sources in 2003 to that in 2005?
Your response must be concise. 0.71. What is the ratio of the Electricity production(% of total) in Coal sources in 2003 to that in 2006?
Your answer should be compact. 1.01. What is the ratio of the Electricity production(% of total) in Natural gas sources in 2003 to that in 2006?
Your answer should be very brief. 0.65. What is the ratio of the Electricity production(% of total) of Oil sources in 2003 to that in 2006?
Ensure brevity in your answer.  1.25. What is the ratio of the Electricity production(% of total) of Coal sources in 2003 to that in 2007?
Keep it short and to the point. 1.18. What is the ratio of the Electricity production(% of total) of Natural gas sources in 2003 to that in 2007?
Give a very brief answer. 0.59. What is the ratio of the Electricity production(% of total) in Oil sources in 2003 to that in 2007?
Your answer should be very brief. 1.3. What is the ratio of the Electricity production(% of total) of Coal sources in 2003 to that in 2008?
Your response must be concise. 1.27. What is the ratio of the Electricity production(% of total) of Natural gas sources in 2003 to that in 2008?
Provide a short and direct response. 0.5. What is the ratio of the Electricity production(% of total) of Oil sources in 2003 to that in 2008?
Keep it short and to the point. 1.48. What is the ratio of the Electricity production(% of total) of Natural gas sources in 2004 to that in 2005?
Offer a very short reply. 0.89. What is the ratio of the Electricity production(% of total) of Oil sources in 2004 to that in 2005?
Your answer should be very brief. 0.67. What is the ratio of the Electricity production(% of total) of Coal sources in 2004 to that in 2006?
Offer a very short reply. 1.08. What is the ratio of the Electricity production(% of total) of Natural gas sources in 2004 to that in 2006?
Ensure brevity in your answer.  1.03. What is the ratio of the Electricity production(% of total) of Oil sources in 2004 to that in 2006?
Offer a very short reply. 1.18. What is the ratio of the Electricity production(% of total) of Coal sources in 2004 to that in 2007?
Offer a very short reply. 1.25. What is the ratio of the Electricity production(% of total) in Natural gas sources in 2004 to that in 2007?
Ensure brevity in your answer.  0.93. What is the ratio of the Electricity production(% of total) of Oil sources in 2004 to that in 2007?
Make the answer very short. 1.22. What is the ratio of the Electricity production(% of total) of Coal sources in 2004 to that in 2008?
Provide a short and direct response. 1.35. What is the ratio of the Electricity production(% of total) of Natural gas sources in 2004 to that in 2008?
Your response must be concise. 0.78. What is the ratio of the Electricity production(% of total) of Oil sources in 2004 to that in 2008?
Make the answer very short. 1.39. What is the ratio of the Electricity production(% of total) of Coal sources in 2005 to that in 2006?
Your answer should be very brief. 1.07. What is the ratio of the Electricity production(% of total) in Natural gas sources in 2005 to that in 2006?
Offer a terse response. 1.16. What is the ratio of the Electricity production(% of total) in Oil sources in 2005 to that in 2006?
Your answer should be compact. 1.76. What is the ratio of the Electricity production(% of total) of Coal sources in 2005 to that in 2007?
Give a very brief answer. 1.25. What is the ratio of the Electricity production(% of total) of Natural gas sources in 2005 to that in 2007?
Your answer should be very brief. 1.05. What is the ratio of the Electricity production(% of total) in Oil sources in 2005 to that in 2007?
Provide a short and direct response. 1.83. What is the ratio of the Electricity production(% of total) of Coal sources in 2005 to that in 2008?
Your response must be concise. 1.34. What is the ratio of the Electricity production(% of total) in Natural gas sources in 2005 to that in 2008?
Give a very brief answer. 0.88. What is the ratio of the Electricity production(% of total) in Oil sources in 2005 to that in 2008?
Your answer should be compact. 2.09. What is the ratio of the Electricity production(% of total) of Coal sources in 2006 to that in 2007?
Make the answer very short. 1.16. What is the ratio of the Electricity production(% of total) in Natural gas sources in 2006 to that in 2007?
Keep it short and to the point. 0.91. What is the ratio of the Electricity production(% of total) of Oil sources in 2006 to that in 2007?
Offer a very short reply. 1.04. What is the ratio of the Electricity production(% of total) in Coal sources in 2006 to that in 2008?
Ensure brevity in your answer.  1.25. What is the ratio of the Electricity production(% of total) of Natural gas sources in 2006 to that in 2008?
Your response must be concise. 0.76. What is the ratio of the Electricity production(% of total) of Oil sources in 2006 to that in 2008?
Offer a very short reply. 1.18. What is the ratio of the Electricity production(% of total) of Coal sources in 2007 to that in 2008?
Ensure brevity in your answer.  1.07. What is the ratio of the Electricity production(% of total) in Natural gas sources in 2007 to that in 2008?
Keep it short and to the point. 0.84. What is the ratio of the Electricity production(% of total) in Oil sources in 2007 to that in 2008?
Your answer should be compact. 1.14. What is the difference between the highest and the second highest Electricity production(% of total) in Coal sources?
Provide a short and direct response. 0.54. What is the difference between the highest and the second highest Electricity production(% of total) in Natural gas sources?
Offer a very short reply. 3.97. What is the difference between the highest and the second highest Electricity production(% of total) of Oil sources?
Make the answer very short. 4.76. What is the difference between the highest and the lowest Electricity production(% of total) of Coal sources?
Ensure brevity in your answer.  9.24. What is the difference between the highest and the lowest Electricity production(% of total) of Natural gas sources?
Keep it short and to the point. 17.8. What is the difference between the highest and the lowest Electricity production(% of total) of Oil sources?
Provide a short and direct response. 15.87. 